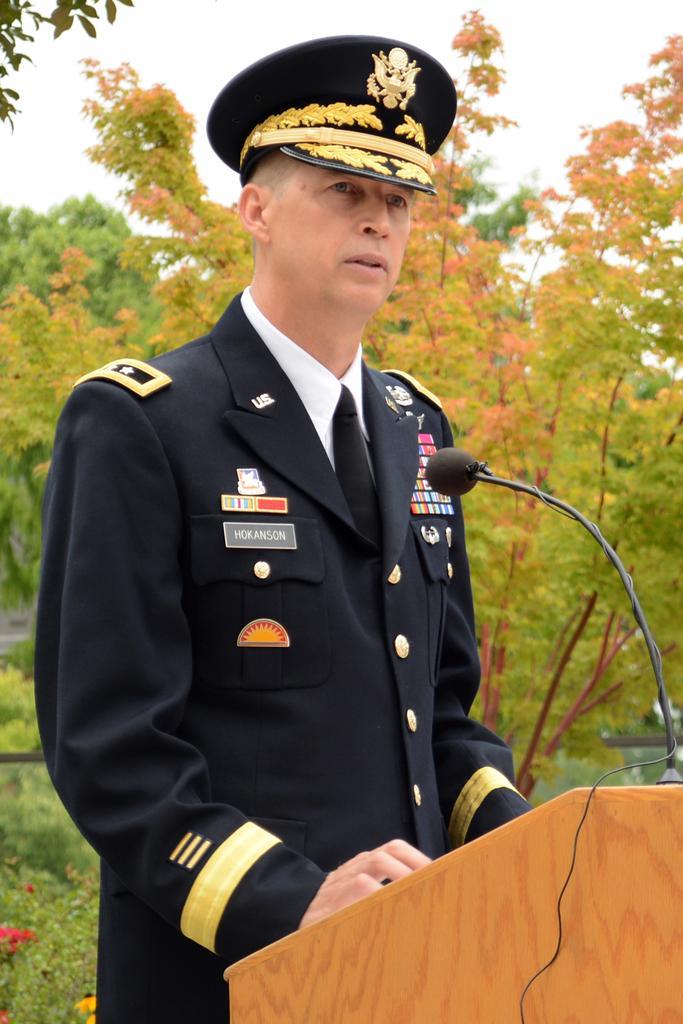Please provide a concise description of this image. In this picture I can see a person standing in front of the mike and talking. 